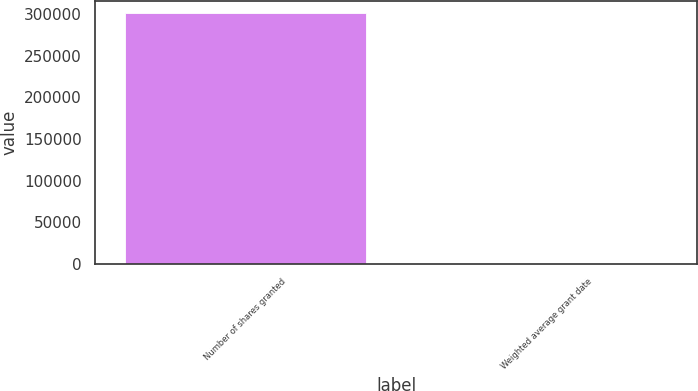Convert chart to OTSL. <chart><loc_0><loc_0><loc_500><loc_500><bar_chart><fcel>Number of shares granted<fcel>Weighted average grant date<nl><fcel>300784<fcel>62.43<nl></chart> 